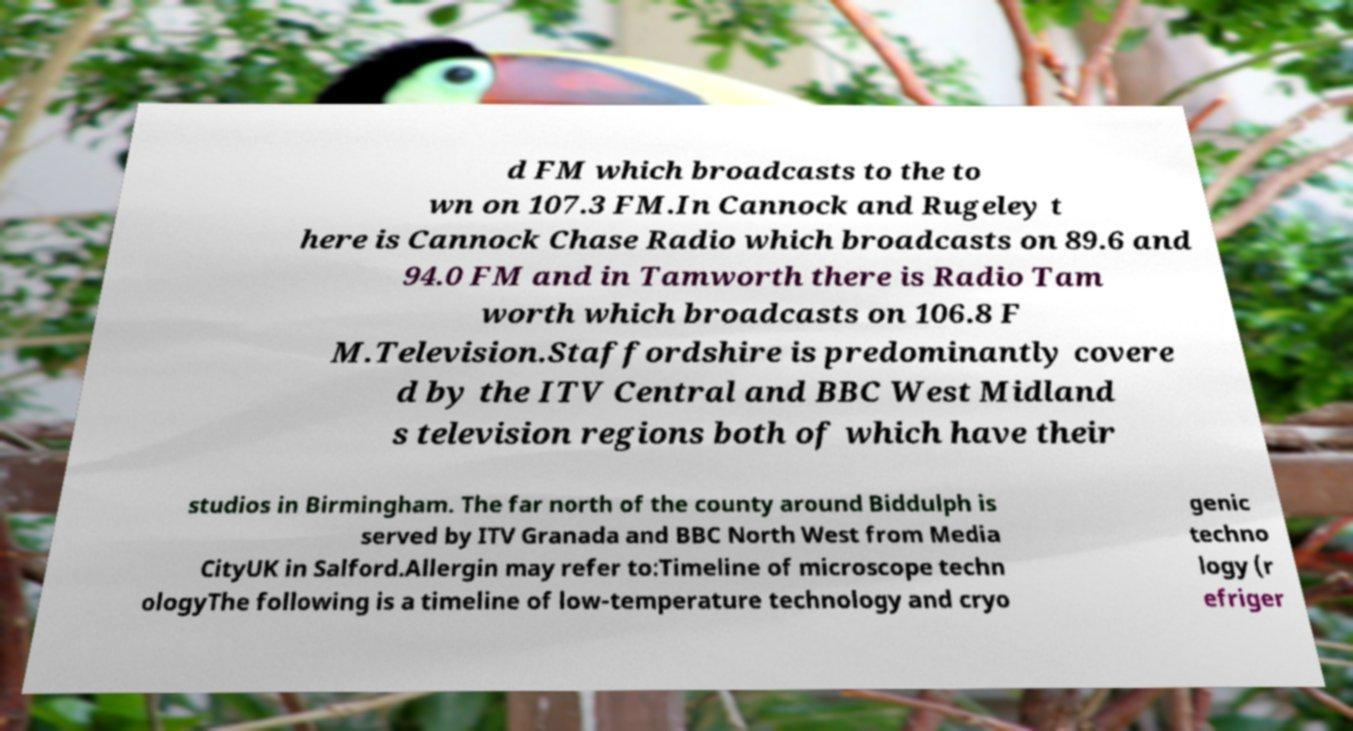Please read and relay the text visible in this image. What does it say? d FM which broadcasts to the to wn on 107.3 FM.In Cannock and Rugeley t here is Cannock Chase Radio which broadcasts on 89.6 and 94.0 FM and in Tamworth there is Radio Tam worth which broadcasts on 106.8 F M.Television.Staffordshire is predominantly covere d by the ITV Central and BBC West Midland s television regions both of which have their studios in Birmingham. The far north of the county around Biddulph is served by ITV Granada and BBC North West from Media CityUK in Salford.Allergin may refer to:Timeline of microscope techn ologyThe following is a timeline of low-temperature technology and cryo genic techno logy (r efriger 